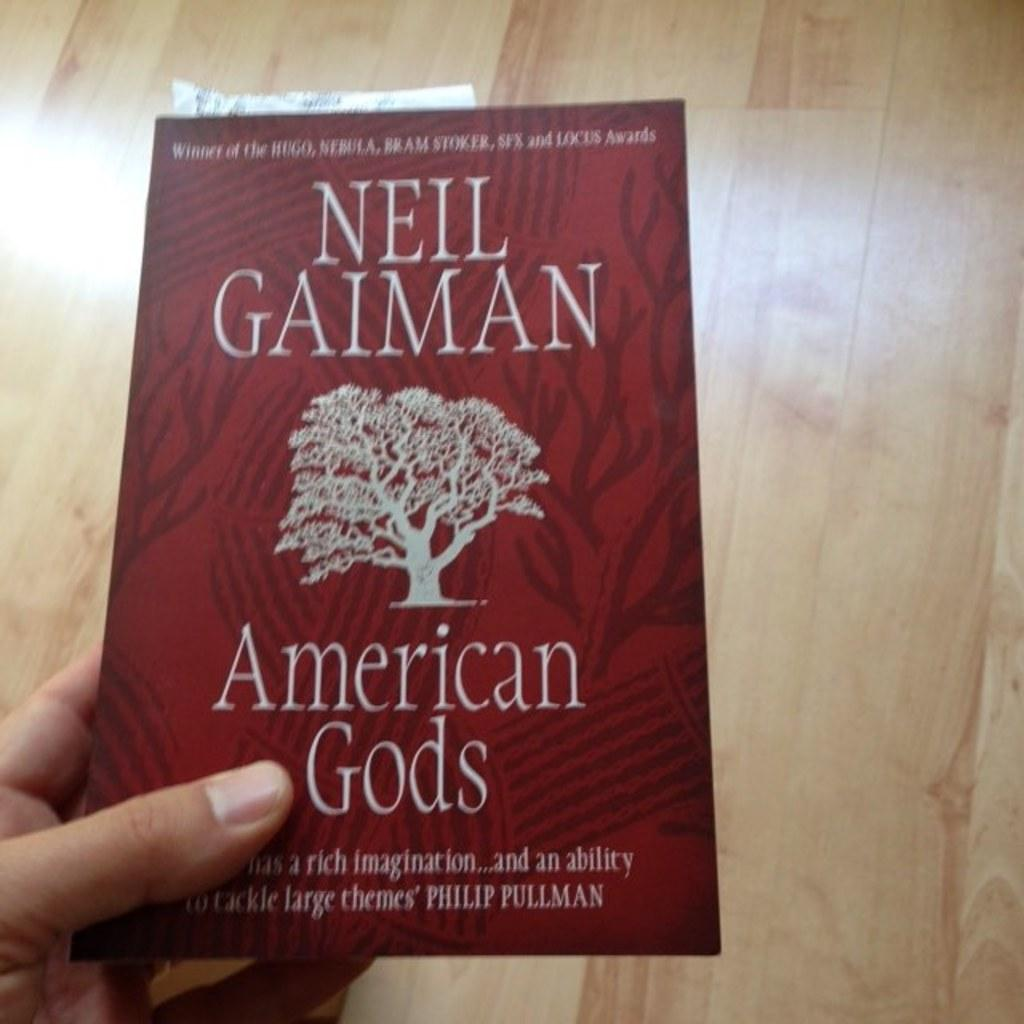<image>
Describe the image concisely. Someone holds out a copy o fNeil Gaiman's American Gods. 